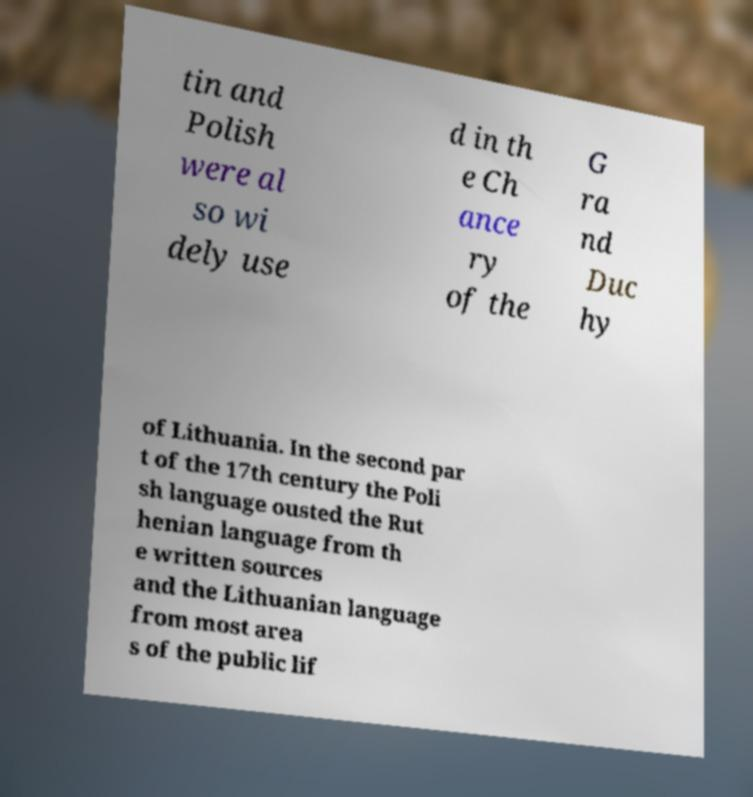What messages or text are displayed in this image? I need them in a readable, typed format. tin and Polish were al so wi dely use d in th e Ch ance ry of the G ra nd Duc hy of Lithuania. In the second par t of the 17th century the Poli sh language ousted the Rut henian language from th e written sources and the Lithuanian language from most area s of the public lif 